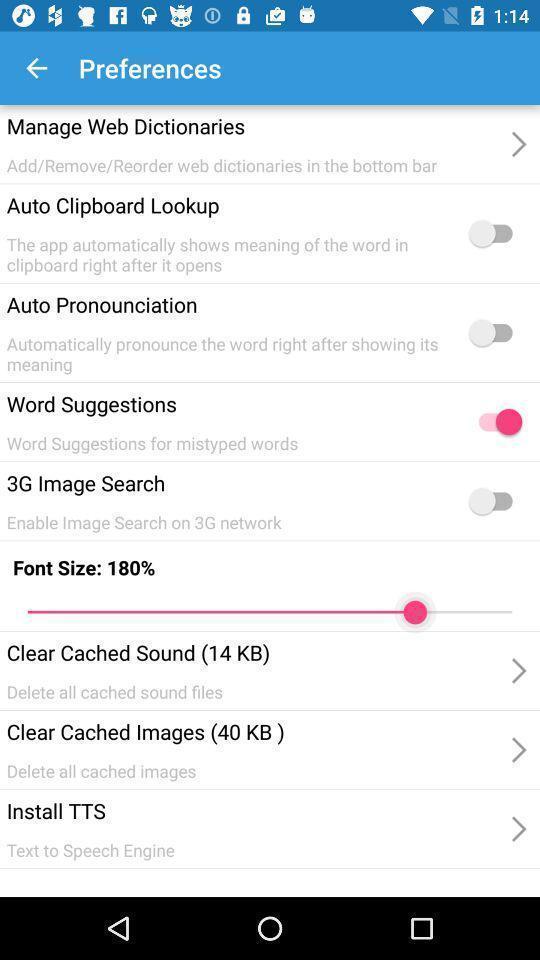Tell me what you see in this picture. Preferences menu in a language translator app. 